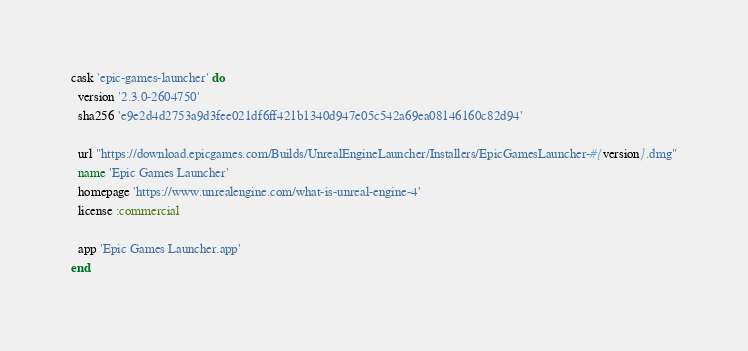<code> <loc_0><loc_0><loc_500><loc_500><_Ruby_>cask 'epic-games-launcher' do
  version '2.3.0-2604750'
  sha256 'e9e2d4d2753a9d3fee021df6ff421b1340d947e05c542a69ea08146160c82d94'

  url "https://download.epicgames.com/Builds/UnrealEngineLauncher/Installers/EpicGamesLauncher-#{version}.dmg"
  name 'Epic Games Launcher'
  homepage 'https://www.unrealengine.com/what-is-unreal-engine-4'
  license :commercial

  app 'Epic Games Launcher.app'
end
</code> 